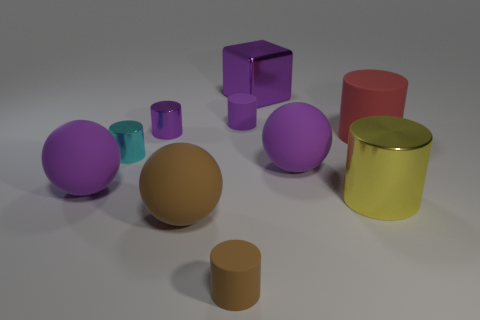Subtract all purple cylinders. How many cylinders are left? 4 Subtract all tiny purple metal cylinders. How many cylinders are left? 5 Subtract all yellow cylinders. Subtract all blue balls. How many cylinders are left? 5 Subtract all blocks. How many objects are left? 9 Add 4 purple metallic cylinders. How many purple metallic cylinders are left? 5 Add 4 small cyan shiny cylinders. How many small cyan shiny cylinders exist? 5 Subtract 1 cyan cylinders. How many objects are left? 9 Subtract all tiny cyan cylinders. Subtract all large yellow cylinders. How many objects are left? 8 